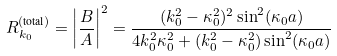<formula> <loc_0><loc_0><loc_500><loc_500>R _ { k _ { 0 } } ^ { ( \text {total} ) } = \left | \frac { B } { A } \right | ^ { 2 } & = \frac { ( k _ { 0 } ^ { 2 } - \kappa _ { 0 } ^ { 2 } ) ^ { 2 } \sin ^ { 2 } ( \kappa _ { 0 } a ) } { 4 k _ { 0 } ^ { 2 } \kappa _ { 0 } ^ { 2 } + ( k _ { 0 } ^ { 2 } - \kappa _ { 0 } ^ { 2 } ) \sin ^ { 2 } ( \kappa _ { 0 } a ) }</formula> 